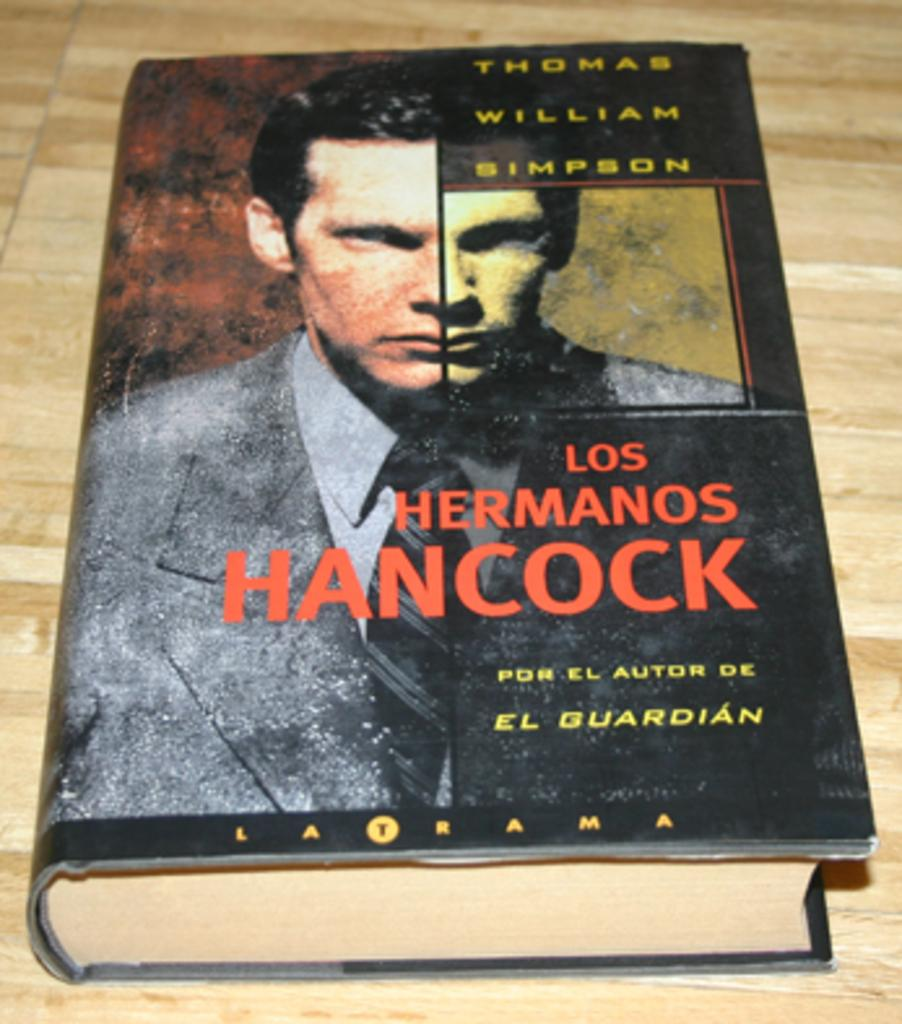<image>
Summarize the visual content of the image. Los Hermanos Hancock chapter book by Thomas William Simpson 